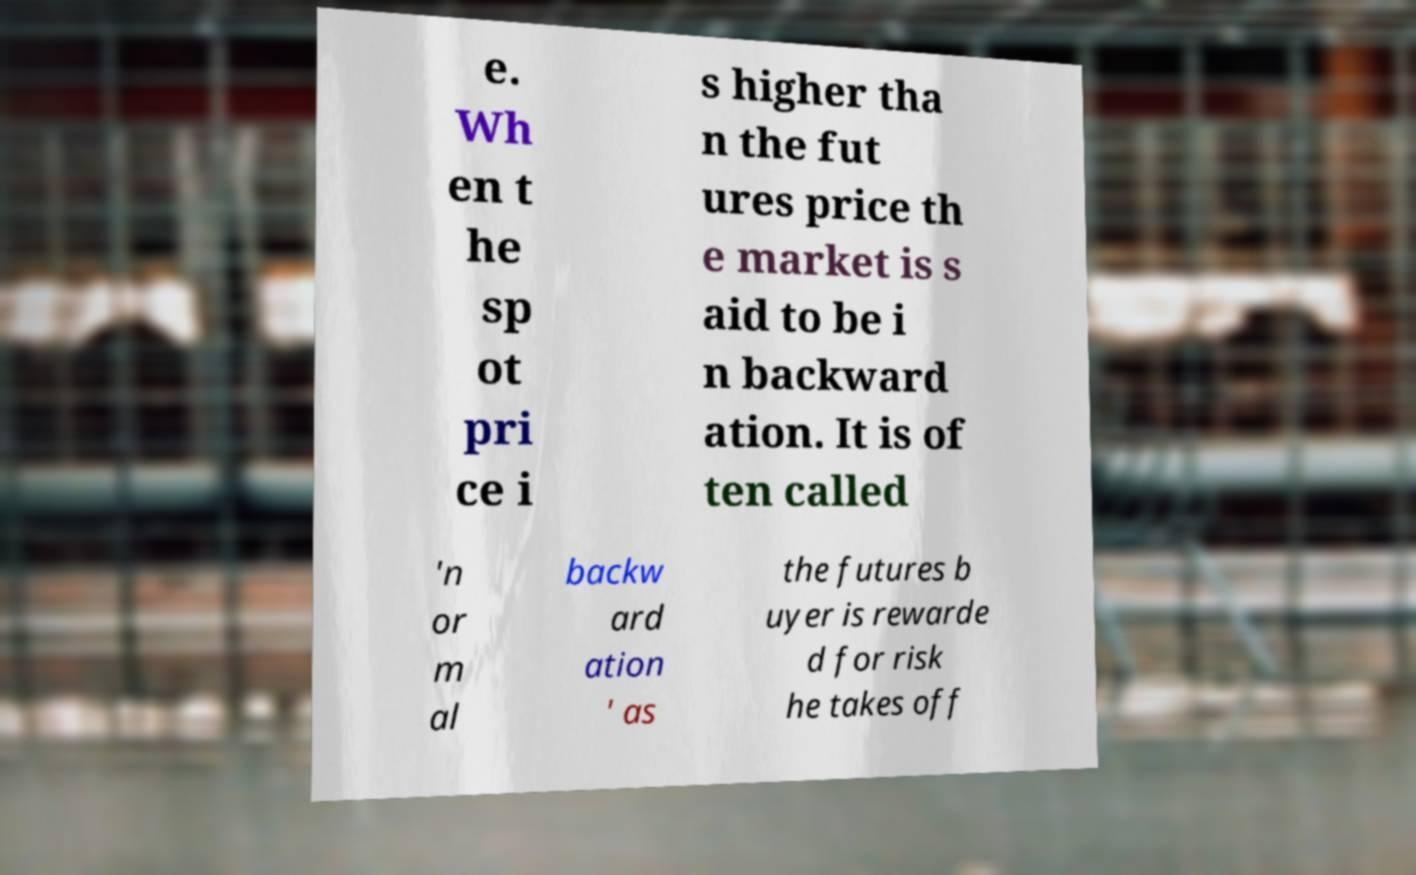Could you assist in decoding the text presented in this image and type it out clearly? e. Wh en t he sp ot pri ce i s higher tha n the fut ures price th e market is s aid to be i n backward ation. It is of ten called 'n or m al backw ard ation ' as the futures b uyer is rewarde d for risk he takes off 